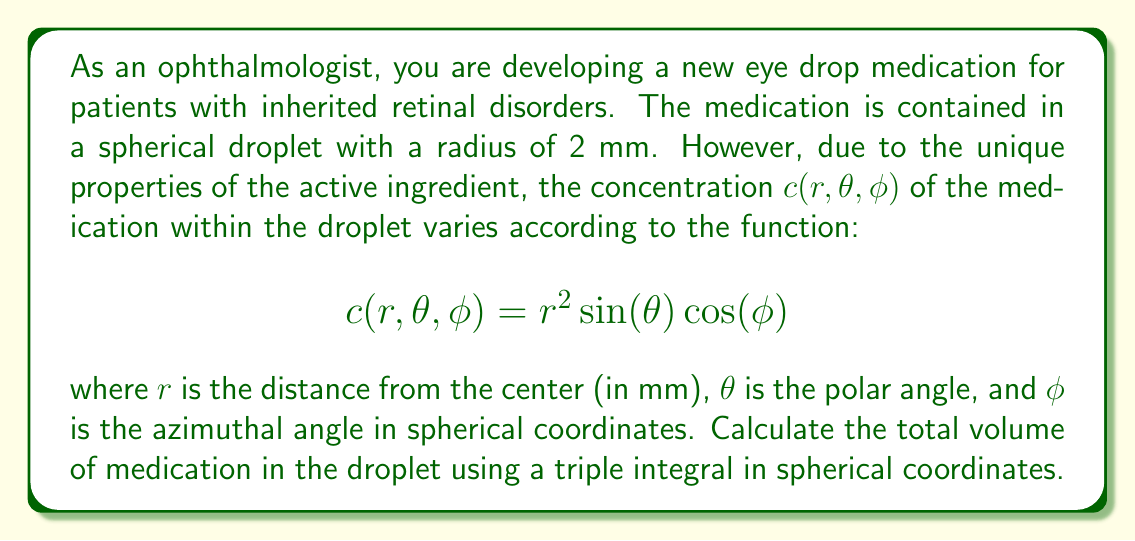Provide a solution to this math problem. To solve this problem, we need to set up and evaluate a triple integral in spherical coordinates. The steps are as follows:

1) In spherical coordinates, the volume element is given by:
   $$dV = r^2 \sin(\theta) \, dr \, d\theta \, d\phi$$

2) The limits of integration are:
   $0 \leq r \leq 2$ (radius from 0 to 2 mm)
   $0 \leq \theta \leq \pi$ (polar angle from 0 to π)
   $0 \leq \phi \leq 2\pi$ (azimuthal angle from 0 to 2π)

3) The triple integral to calculate the volume is:

   $$V = \int_0^{2\pi} \int_0^{\pi} \int_0^2 c(r,\theta,\phi) \cdot r^2 \sin(\theta) \, dr \, d\theta \, d\phi$$

4) Substituting the concentration function:

   $$V = \int_0^{2\pi} \int_0^{\pi} \int_0^2 r^2 \sin(\theta) \cos(\phi) \cdot r^2 \sin(\theta) \, dr \, d\theta \, d\phi$$

5) Simplify:

   $$V = \int_0^{2\pi} \int_0^{\pi} \int_0^2 r^4 \sin^2(\theta) \cos(\phi) \, dr \, d\theta \, d\phi$$

6) Evaluate the integral with respect to $r$:

   $$V = \int_0^{2\pi} \int_0^{\pi} \left[\frac{r^5}{5}\right]_0^2 \sin^2(\theta) \cos(\phi) \, d\theta \, d\phi$$
   $$V = \frac{32}{5} \int_0^{2\pi} \int_0^{\pi} \sin^2(\theta) \cos(\phi) \, d\theta \, d\phi$$

7) Evaluate the integral with respect to $\theta$:

   $$V = \frac{32}{5} \int_0^{2\pi} \left[-\frac{1}{4}\cos(\theta)\sin(\theta) + \frac{\theta}{4}\right]_0^{\pi} \cos(\phi) \, d\phi$$
   $$V = \frac{32}{5} \int_0^{2\pi} \frac{\pi}{4} \cos(\phi) \, d\phi$$

8) Evaluate the final integral with respect to $\phi$:

   $$V = \frac{8\pi}{5} \left[\sin(\phi)\right]_0^{2\pi} = 0$$

Therefore, the total volume of medication in the droplet is 0 mm³.
Answer: $0 \text{ mm}^3$ 